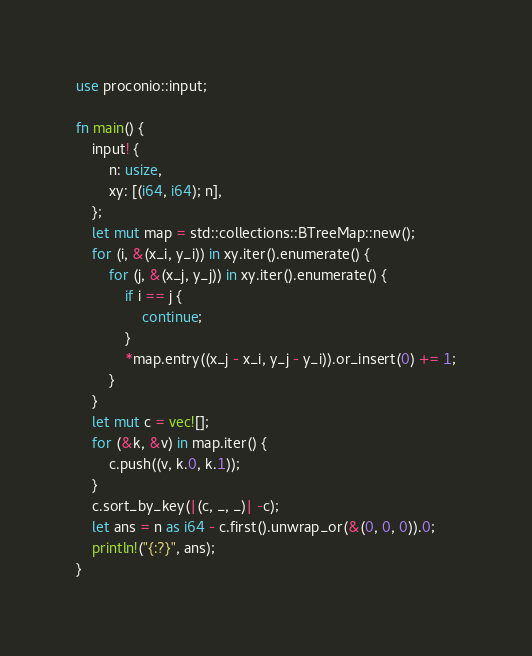<code> <loc_0><loc_0><loc_500><loc_500><_Rust_>use proconio::input;

fn main() {
    input! {
        n: usize,
        xy: [(i64, i64); n],
    };
    let mut map = std::collections::BTreeMap::new();
    for (i, &(x_i, y_i)) in xy.iter().enumerate() {
        for (j, &(x_j, y_j)) in xy.iter().enumerate() {
            if i == j {
                continue;
            }
            *map.entry((x_j - x_i, y_j - y_i)).or_insert(0) += 1;
        }
    }
    let mut c = vec![];
    for (&k, &v) in map.iter() {
        c.push((v, k.0, k.1));
    }
    c.sort_by_key(|(c, _, _)| -c);
    let ans = n as i64 - c.first().unwrap_or(&(0, 0, 0)).0;
    println!("{:?}", ans);
}
</code> 